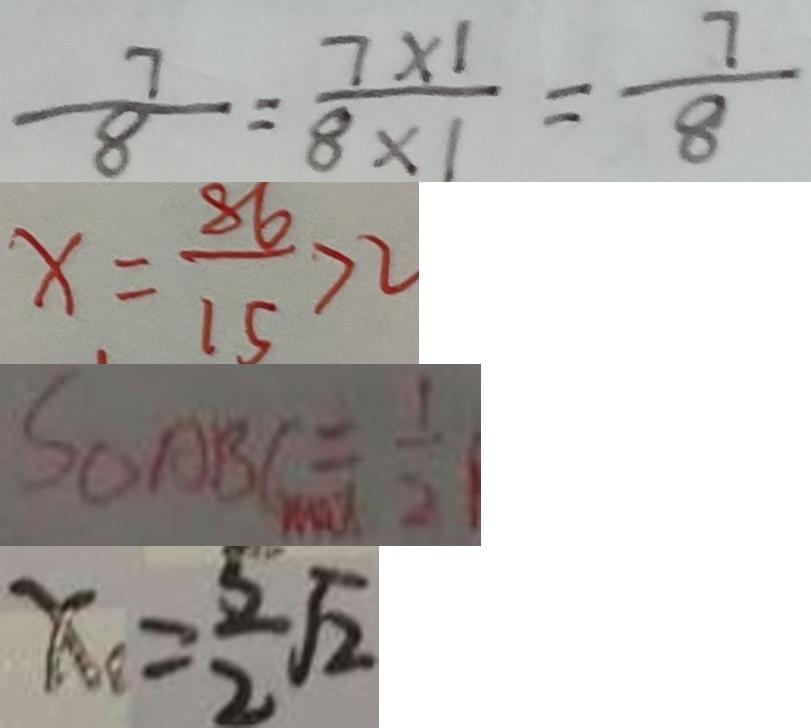Convert formula to latex. <formula><loc_0><loc_0><loc_500><loc_500>\frac { 7 } { 8 } = \frac { 7 \times 1 } { 8 \times 1 } = \frac { 7 } { 8 } 
 x = \frac { 8 6 } { 1 5 } > 2 
 S _ { \Delta } A B C = \frac { 1 } { 2 } 
 x _ { 1 } = \frac { 5 } { 2 } \sqrt { 2 }</formula> 